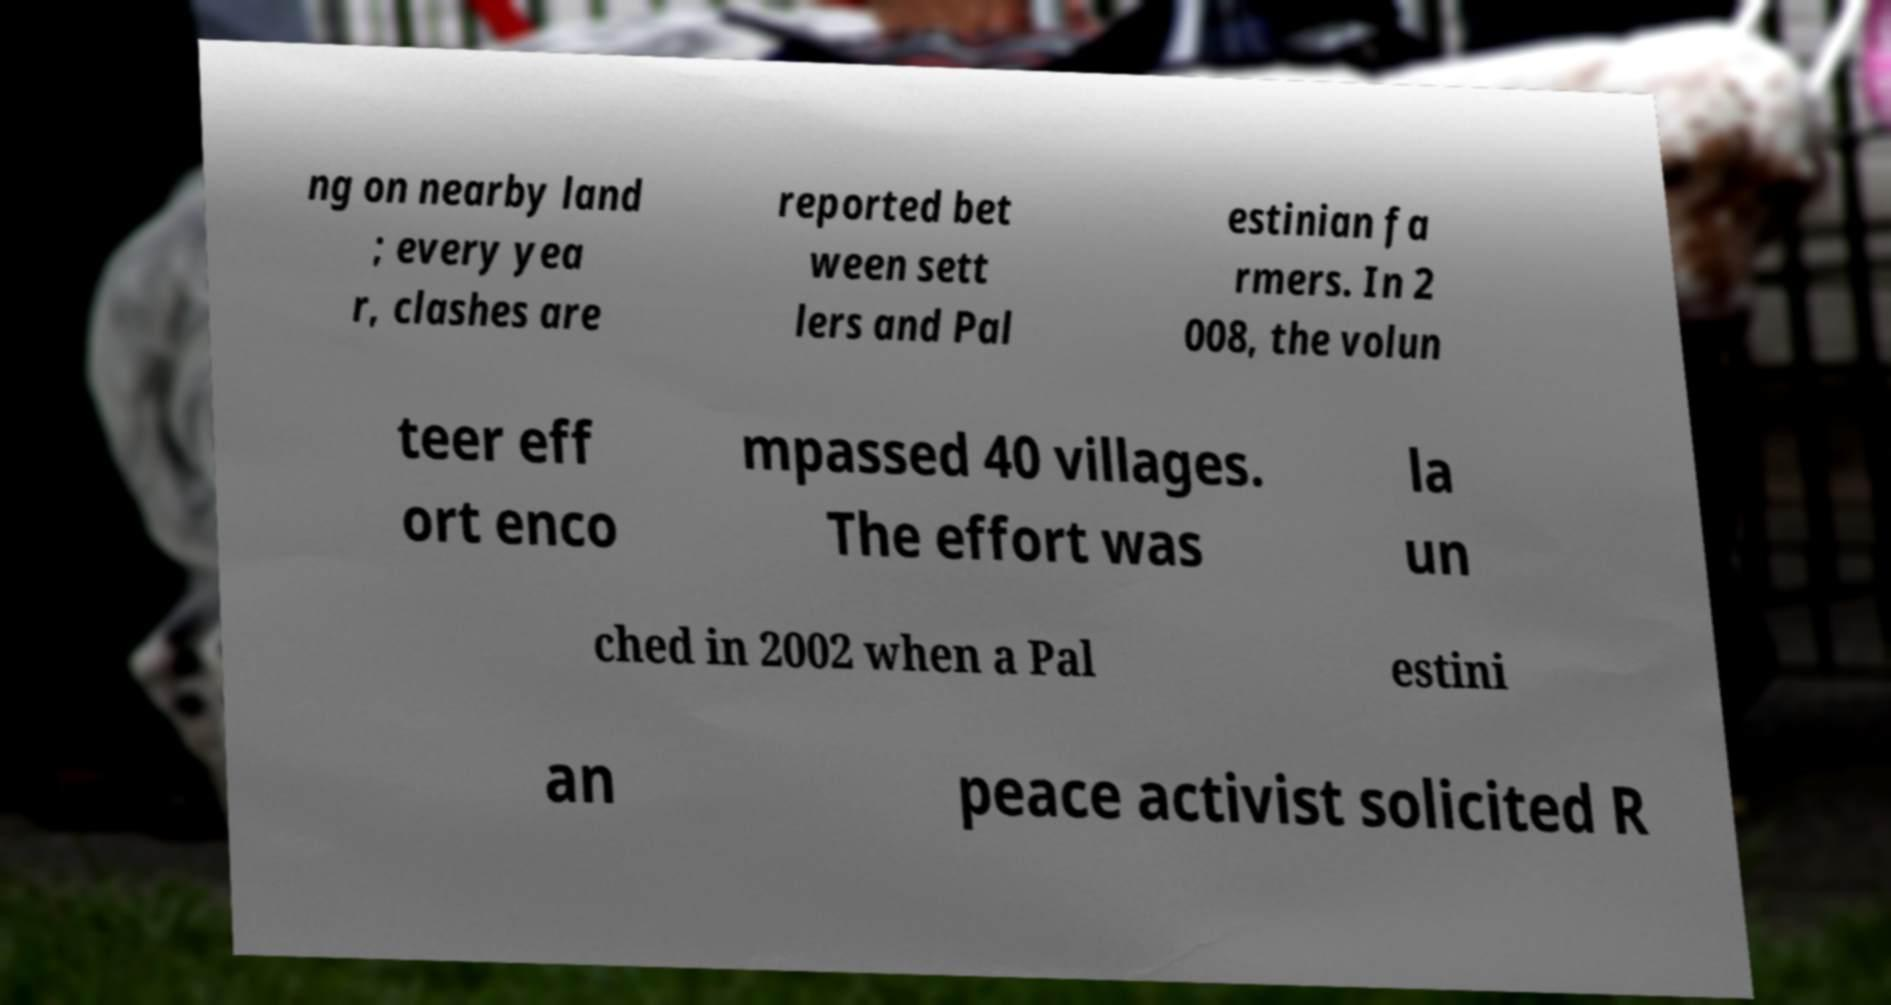Could you assist in decoding the text presented in this image and type it out clearly? ng on nearby land ; every yea r, clashes are reported bet ween sett lers and Pal estinian fa rmers. In 2 008, the volun teer eff ort enco mpassed 40 villages. The effort was la un ched in 2002 when a Pal estini an peace activist solicited R 